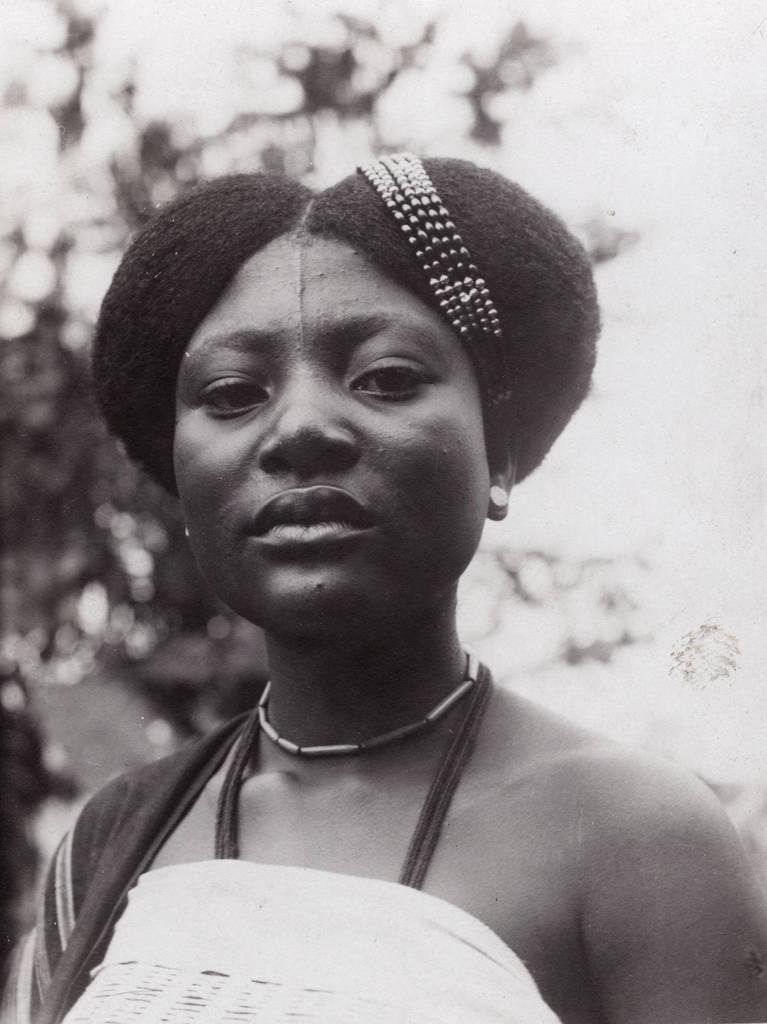What is the main subject of the image? There is a person in the image. What is the person wearing? The person is wearing clothes. What is on the person's head? There is an object on the person's head. How would you describe the background of the image? The background of the image is blurred. What is the color scheme of the image? The image is black and white. How many pizzas can be seen in the image? There are no pizzas present in the image. Is the person's mom visible in the image? The text does not mention the person's mom, and there is no indication of her presence in the image. 